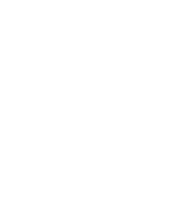<code> <loc_0><loc_0><loc_500><loc_500><_Python_>

</code> 